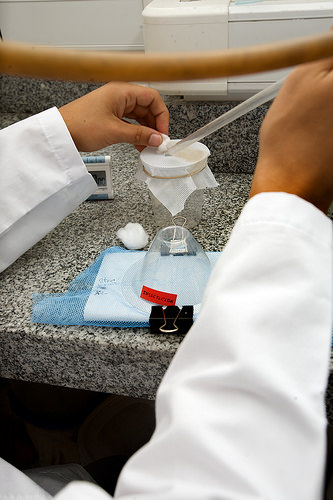<image>
Is there a black pants under the counter? Yes. The black pants is positioned underneath the counter, with the counter above it in the vertical space. 